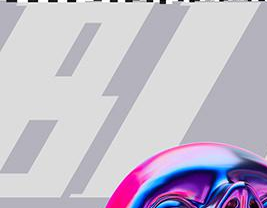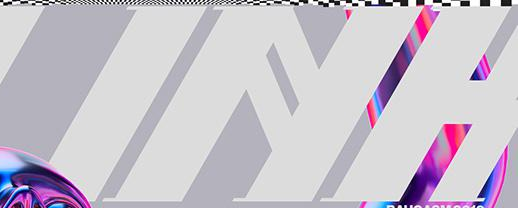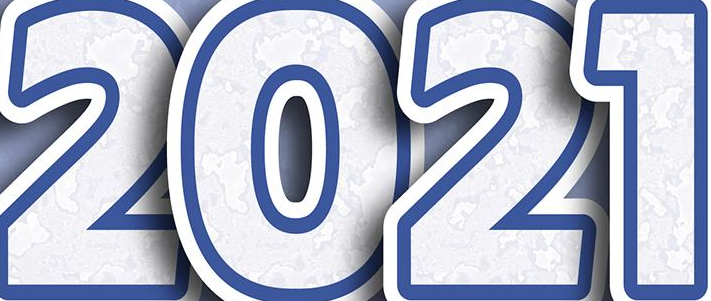Identify the words shown in these images in order, separated by a semicolon. BI; INH; 2021 